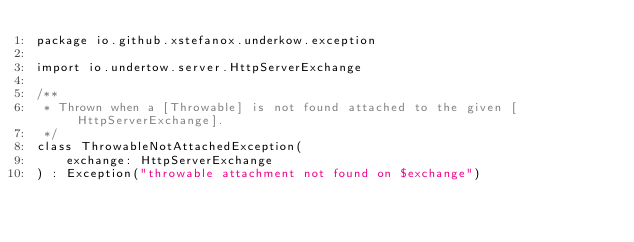Convert code to text. <code><loc_0><loc_0><loc_500><loc_500><_Kotlin_>package io.github.xstefanox.underkow.exception

import io.undertow.server.HttpServerExchange

/**
 * Thrown when a [Throwable] is not found attached to the given [HttpServerExchange].
 */
class ThrowableNotAttachedException(
    exchange: HttpServerExchange
) : Exception("throwable attachment not found on $exchange")
</code> 